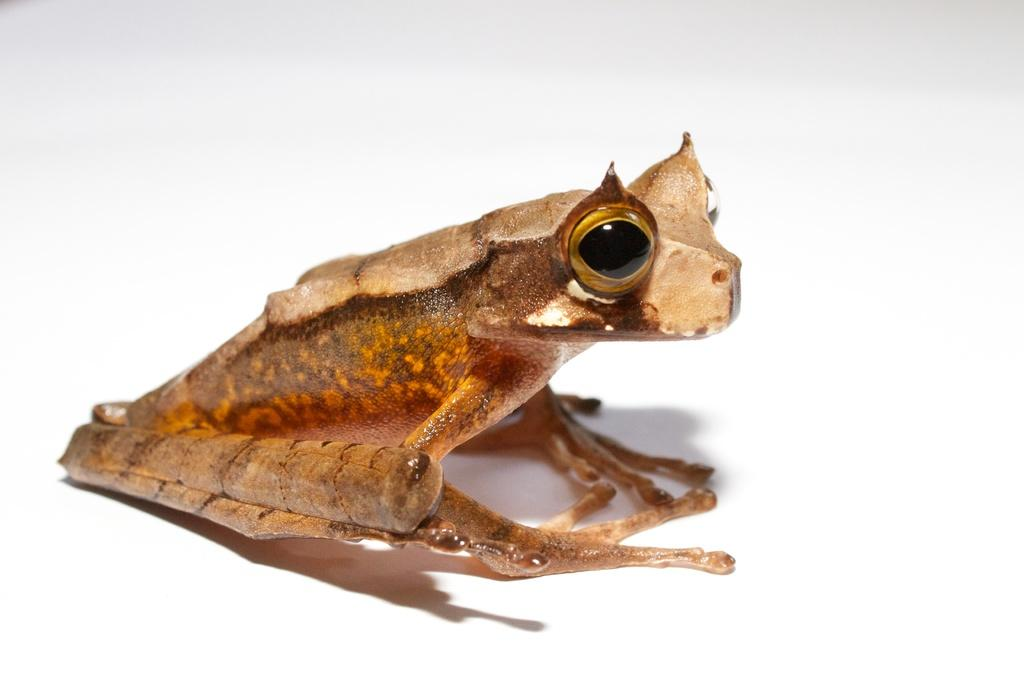What type of animal is in the image? There is a frog in the image. What colors can be seen on the frog? The frog has cream and brown colors. What color is the background of the image? The background of the image is white. How many babies are being held by the frog in the image? There are no babies present in the image; it features a frog with cream and brown colors against a white background. What type of footwear is visible on the frog's feet in the image? There is no footwear visible on the frog's feet in the image, as frogs do not wear shoes. 